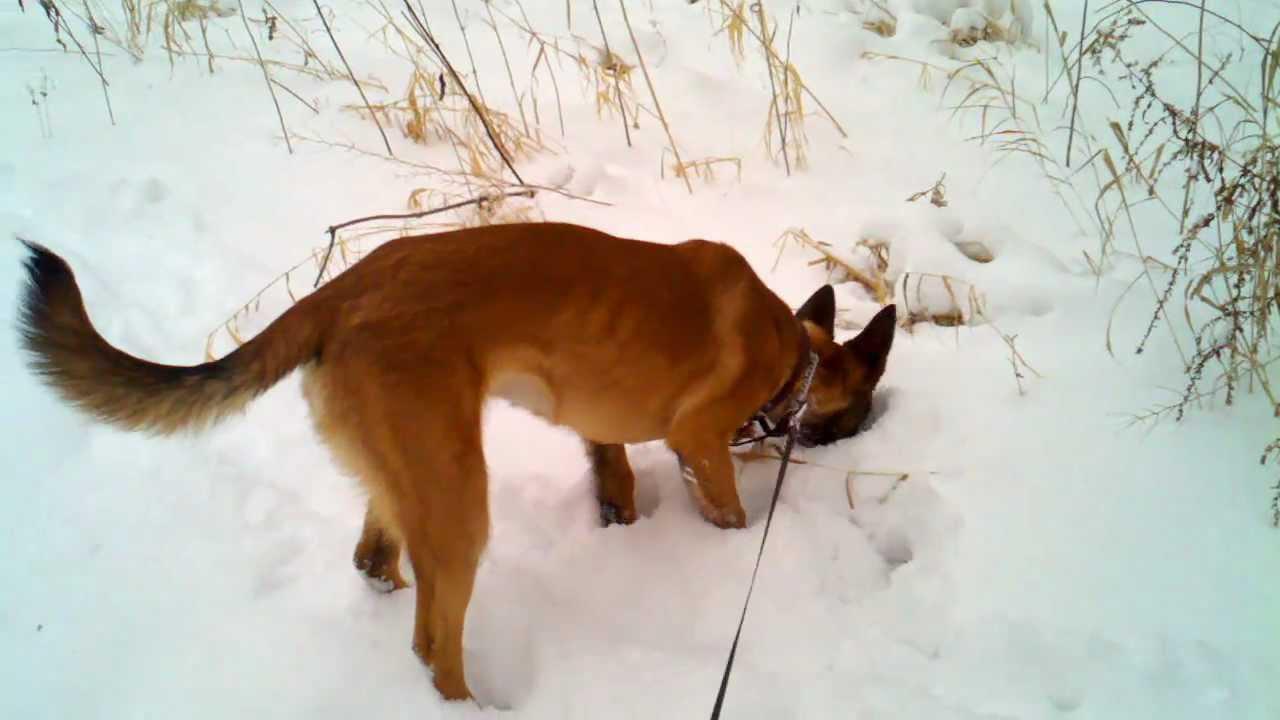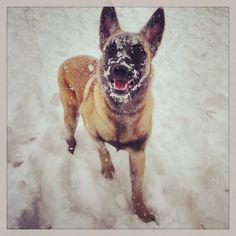The first image is the image on the left, the second image is the image on the right. For the images displayed, is the sentence "The dog in the image on the left is baring its teeth." factually correct? Answer yes or no. No. The first image is the image on the left, the second image is the image on the right. Evaluate the accuracy of this statement regarding the images: "An image shows one german shepherd dog with a dusting of snow on the fur of its face.". Is it true? Answer yes or no. Yes. 